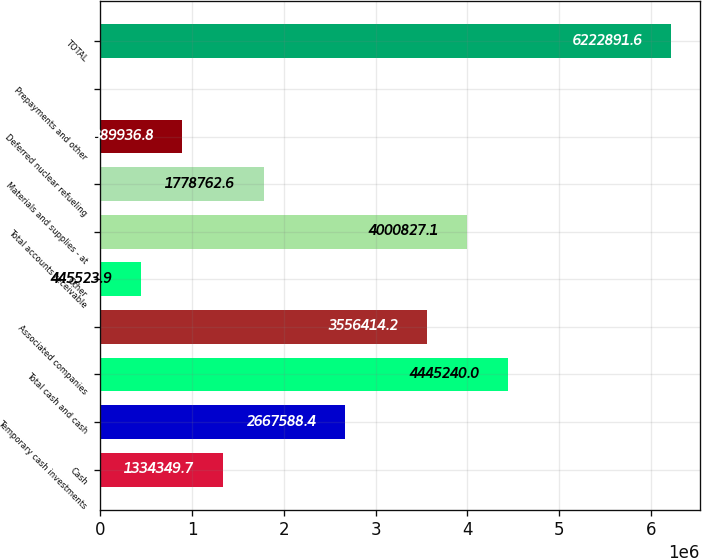Convert chart. <chart><loc_0><loc_0><loc_500><loc_500><bar_chart><fcel>Cash<fcel>Temporary cash investments<fcel>Total cash and cash<fcel>Associated companies<fcel>Other<fcel>Total accounts receivable<fcel>Materials and supplies - at<fcel>Deferred nuclear refueling<fcel>Prepayments and other<fcel>TOTAL<nl><fcel>1.33435e+06<fcel>2.66759e+06<fcel>4.44524e+06<fcel>3.55641e+06<fcel>445524<fcel>4.00083e+06<fcel>1.77876e+06<fcel>889937<fcel>1111<fcel>6.22289e+06<nl></chart> 